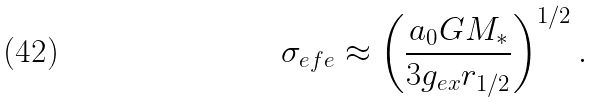Convert formula to latex. <formula><loc_0><loc_0><loc_500><loc_500>\sigma _ { e f e } \approx \left ( \frac { a _ { 0 } G M _ { * } } { 3 g _ { e x } r _ { 1 / 2 } } \right ) ^ { 1 / 2 } .</formula> 